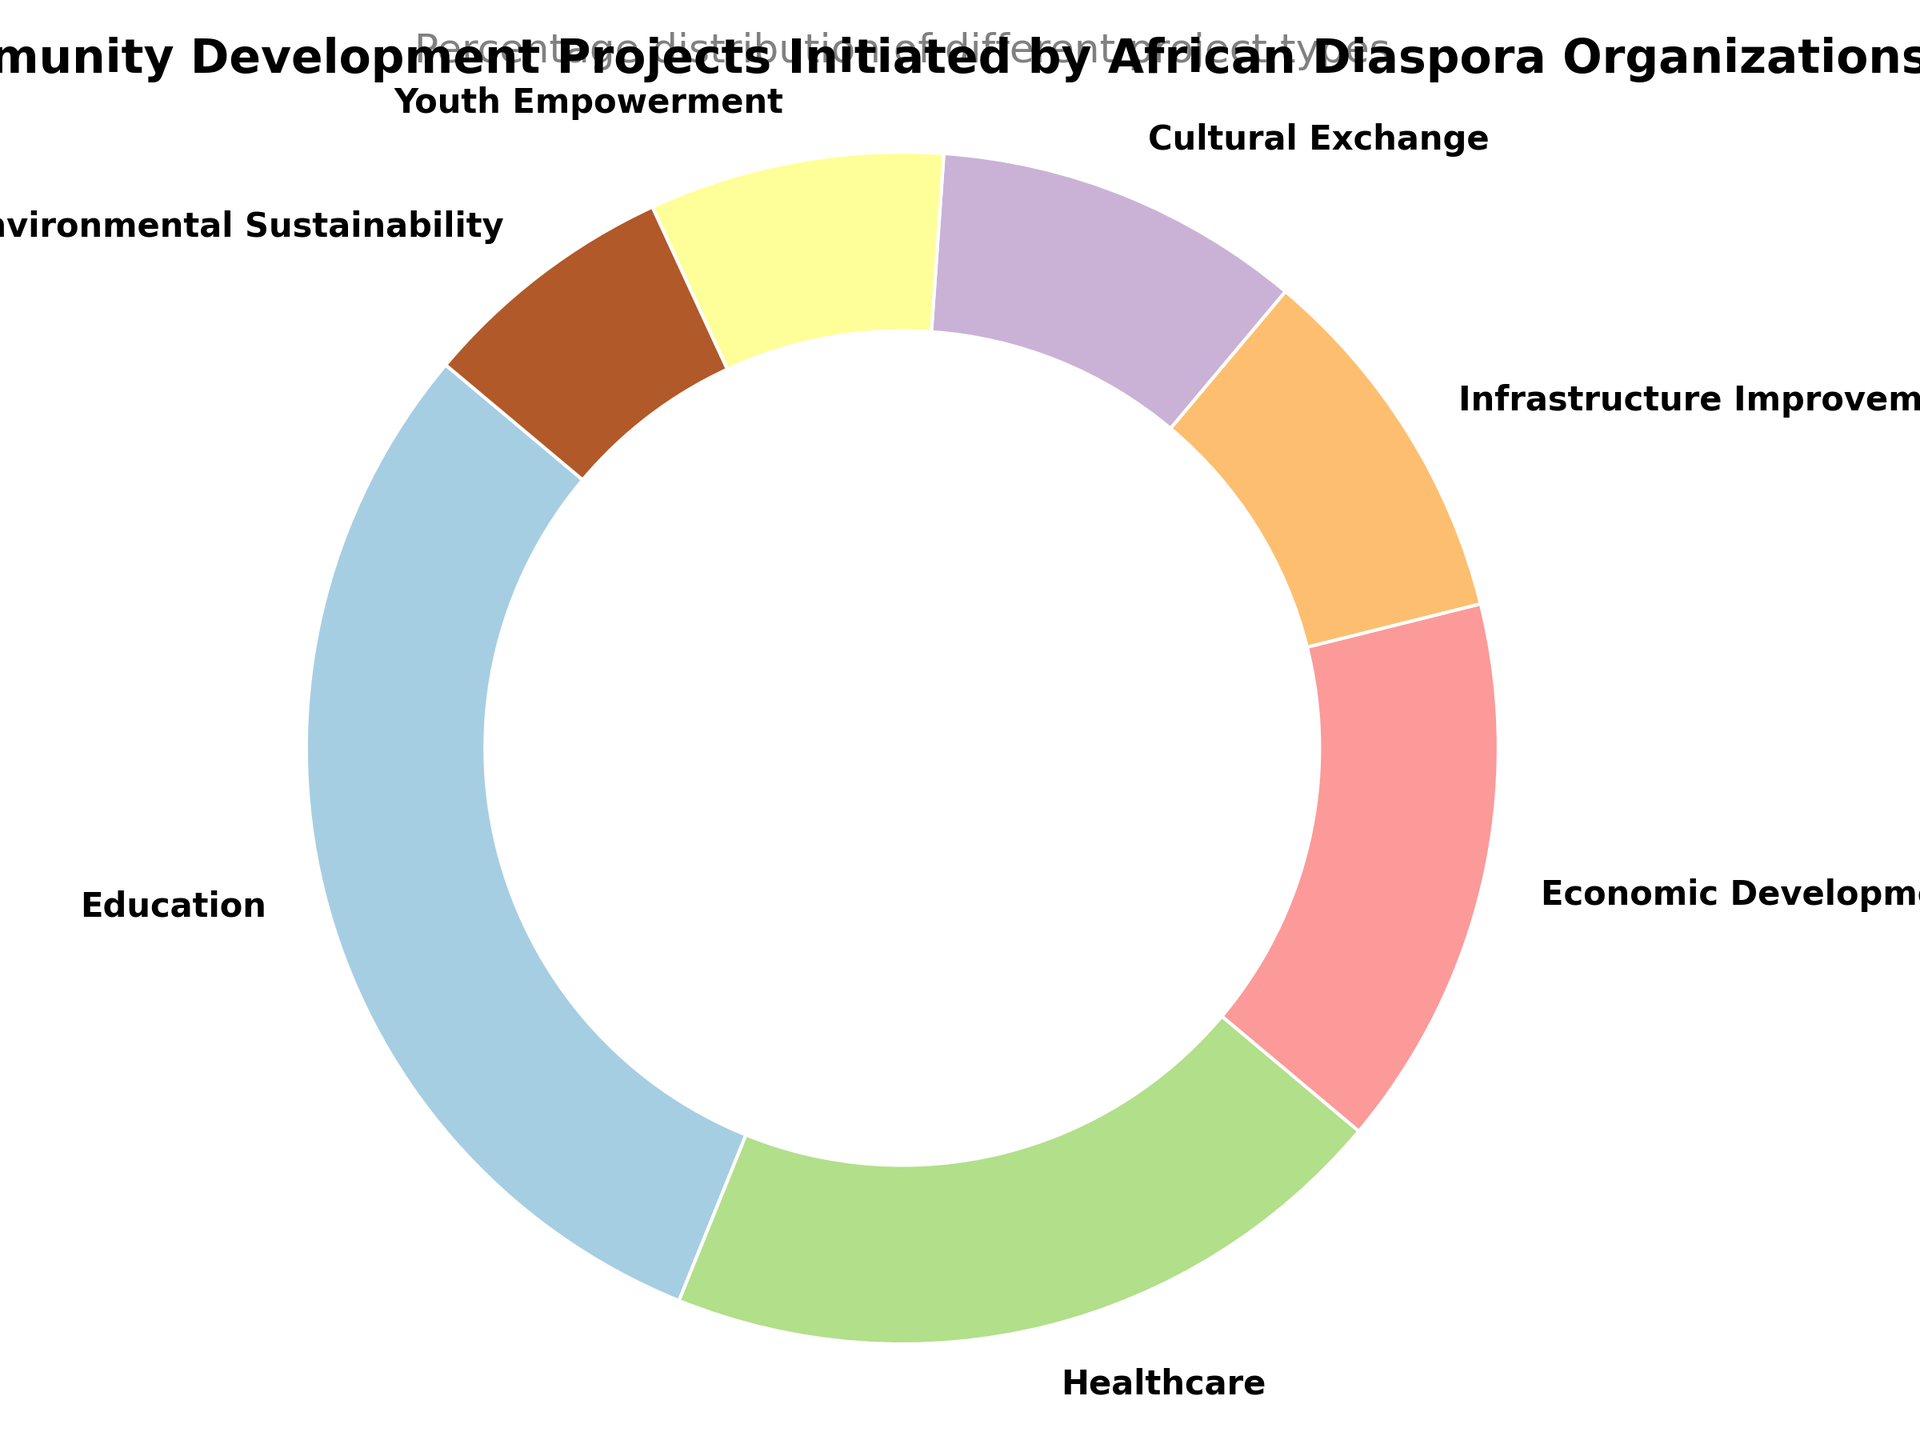what type of project has the highest percentage? By looking at the pie chart, observe which slice is the largest and check its label. The largest slice represents the type of project with the highest percentage.
Answer: Education What is the combined percentage of Infrastructure Improvement and Cultural Exchange projects? Find the percentages of Infrastructure Improvement and Cultural Exchange projects from the chart. Add these two percentages together: 10% (Infrastructure Improvement) + 10% (Cultural Exchange) = 20%.
Answer: 20% Which sector has a larger share: Healthcare or Economic Development? Identify the slices corresponding to Healthcare and Economic Development projects in the pie chart. Compare their percentages: Healthcare (20%) and Economic Development (15%). Healthcare has a larger share.
Answer: Healthcare What is the total percentage of projects focused on youth and environment? Look for the percentages of Youth Empowerment and Environmental Sustainability projects in the chart. Add these two percentages together: 8% (Youth Empowerment) + 7% (Environmental Sustainability) = 15%.
Answer: 15% Which project type has the smallest share? Identify the smallest slice in the pie chart and read its label. The smallest slice represents the project type with the smallest share.
Answer: Environmental Sustainability Compare the combined percentage of Healthcare and Education projects with the combined percentage of all other project types. First calculate the combined percentage of Healthcare and Education: 20% (Healthcare) + 30% (Education) = 50%. Next, calculate the combined percentage of all other project types by summing their percentages: 15% + 10% + 10% + 8% + 7% = 50%. Both combined percentages are equal.
Answer: Equal What is the difference in percentage between Economic Development and Youth Empowerment projects? Find the percentages for Economic Development (15%) and Youth Empowerment (8%) projects. Subtract the smaller percentage from the larger: 15% - 8% = 7%.
Answer: 7% How many project types are represented in the chart? Count the different labels marked on the slices of the pie chart.
Answer: 7 